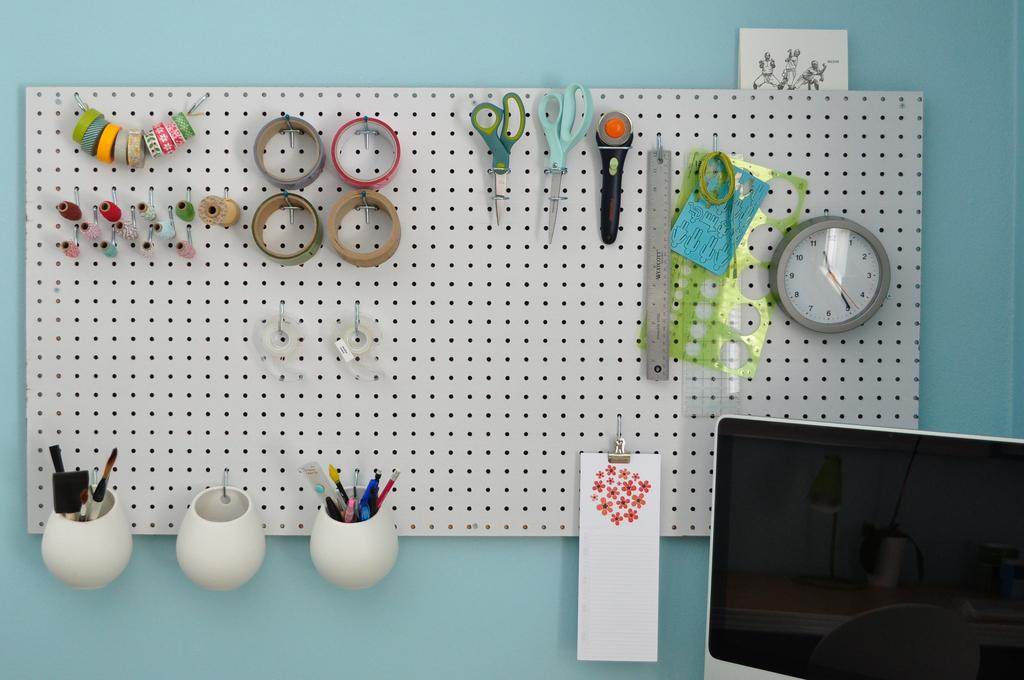What type of stationery item can be seen in the image? There are scissors and a pen stand in the image. What is used for measuring time in the image? There is a clock in the image. What is used for writing in the image? There is a pen stand in the image. What is used for holding paper in the image? There is a pad in the image. What is attached to the wall in the image? The board is kept on the wall. How many friends are visible in the image? There are no friends visible in the image; it only contains stationery items and a board on the wall. What type of knee support can be seen in the image? There is no knee support present in the image. 